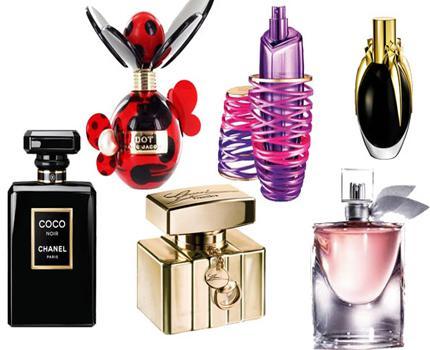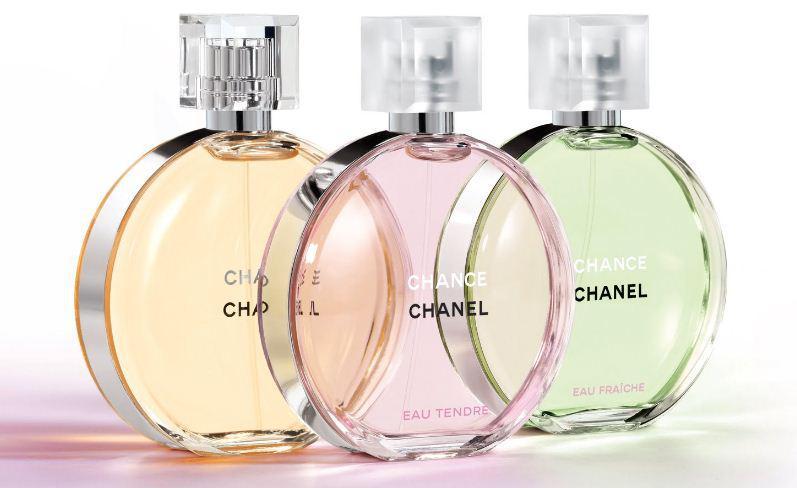The first image is the image on the left, the second image is the image on the right. Evaluate the accuracy of this statement regarding the images: "There are six bottles grouped together in the image on the left.". Is it true? Answer yes or no. Yes. The first image is the image on the left, the second image is the image on the right. Analyze the images presented: Is the assertion "The left image features a horizontal row of at least five different fragrance bottle shapes, while the right image shows at least one bottle in front of its box." valid? Answer yes or no. No. 